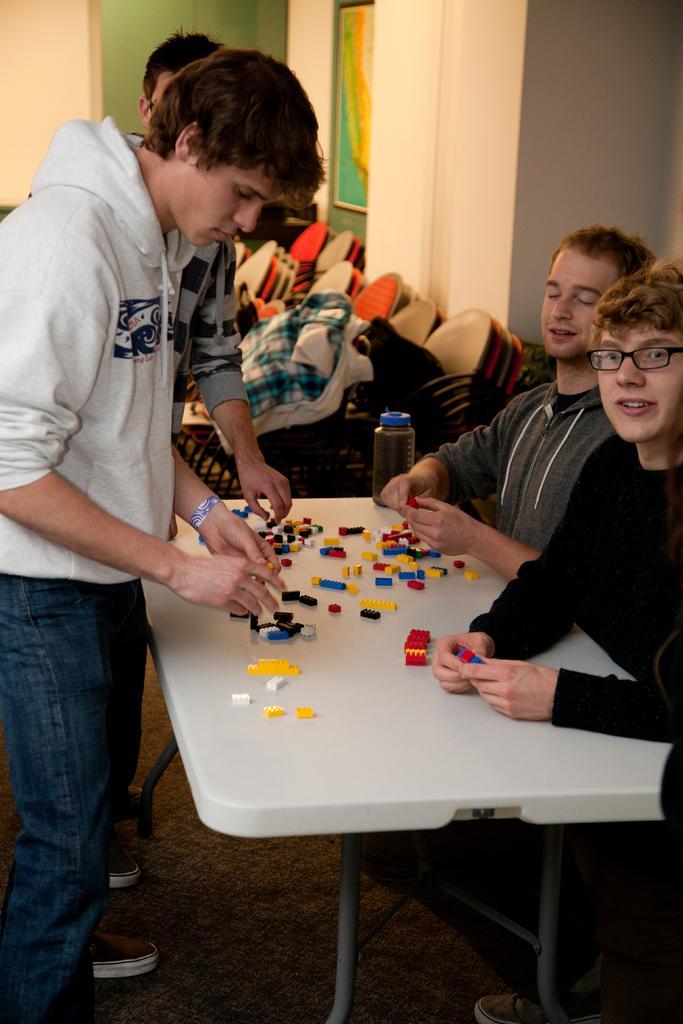Can you describe this image briefly? There are two persons sitting in the right corner and there are two persons standing in the left corner and there is a table in front of them which has some objects on it. The background wall is white in color. 